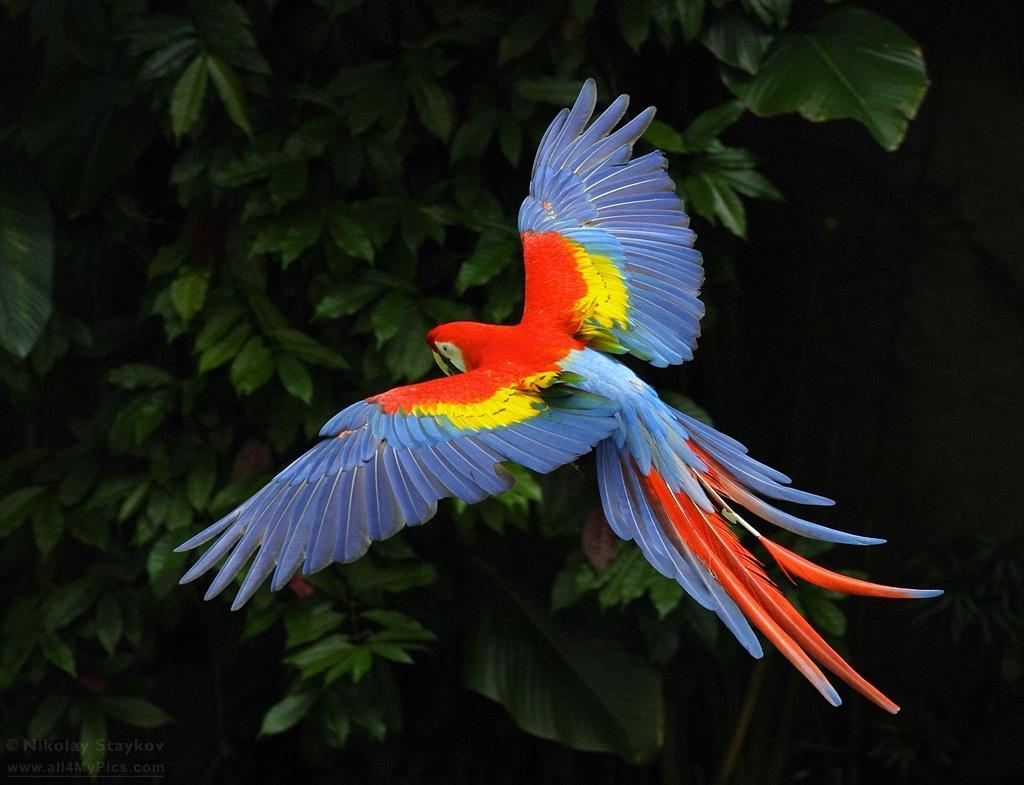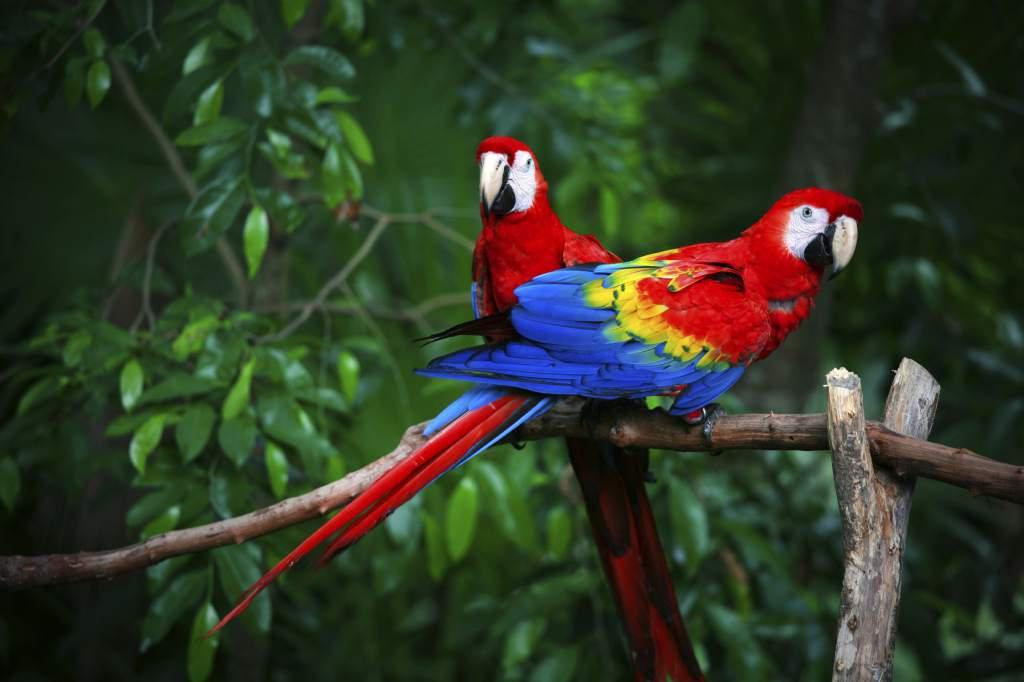The first image is the image on the left, the second image is the image on the right. Analyze the images presented: Is the assertion "An image shows a single parrot in flight." valid? Answer yes or no. Yes. 